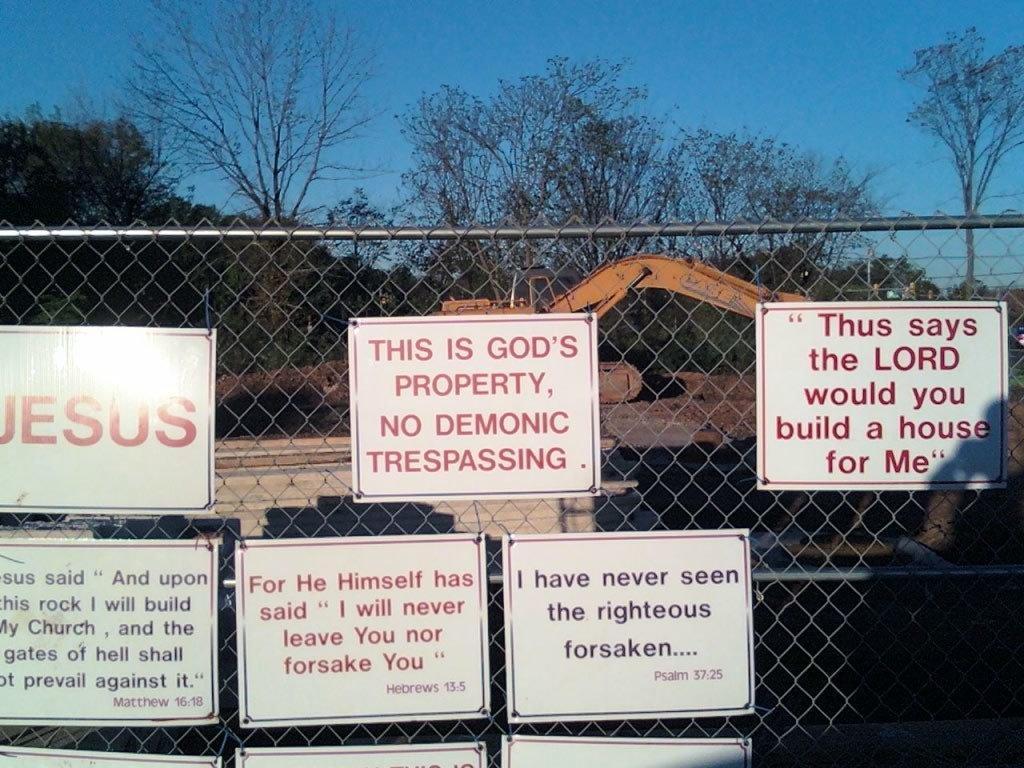Please provide a concise description of this image. In this image I can see few boards attached to a net fencing. On the boards I can see the text. In the background there is a bulldozer and trees. At the top of the image I can see the sky. 